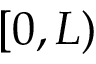Convert formula to latex. <formula><loc_0><loc_0><loc_500><loc_500>[ 0 , L )</formula> 